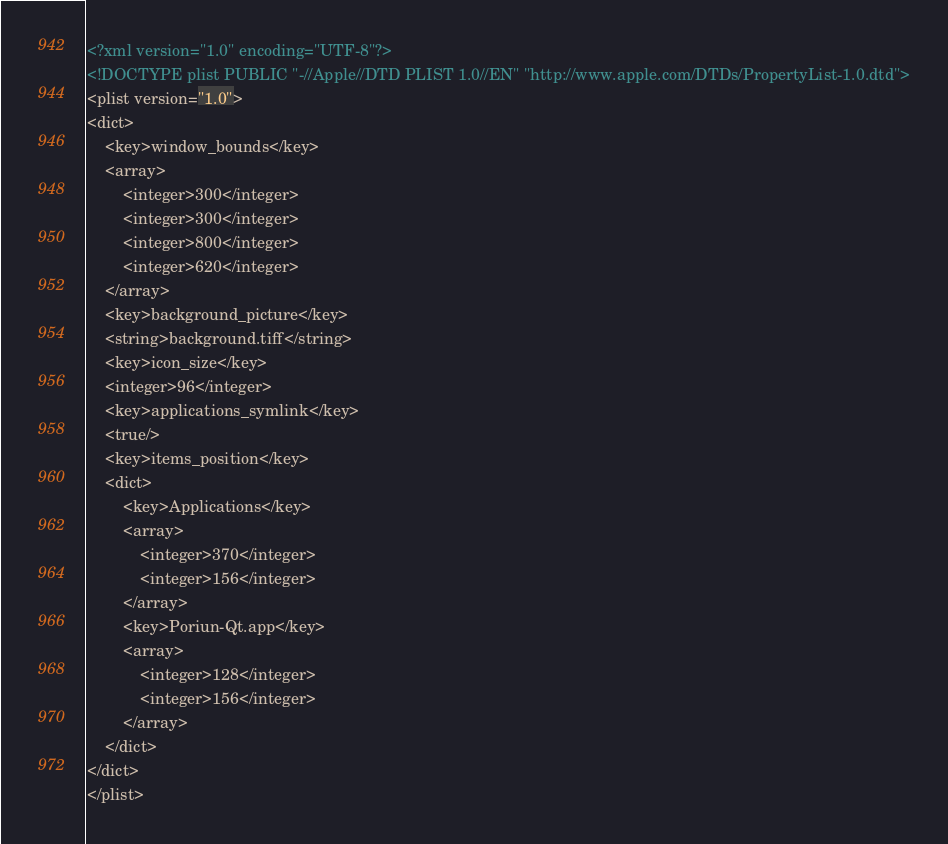Convert code to text. <code><loc_0><loc_0><loc_500><loc_500><_XML_><?xml version="1.0" encoding="UTF-8"?>
<!DOCTYPE plist PUBLIC "-//Apple//DTD PLIST 1.0//EN" "http://www.apple.com/DTDs/PropertyList-1.0.dtd">
<plist version="1.0">
<dict>
	<key>window_bounds</key>
	<array>
		<integer>300</integer>
		<integer>300</integer>
		<integer>800</integer>
		<integer>620</integer>
	</array>
	<key>background_picture</key>
	<string>background.tiff</string>
	<key>icon_size</key>
	<integer>96</integer>
	<key>applications_symlink</key>
	<true/>
	<key>items_position</key>
	<dict>
		<key>Applications</key>
		<array>
			<integer>370</integer>
			<integer>156</integer>
		</array>
		<key>Poriun-Qt.app</key>
		<array>
			<integer>128</integer>
			<integer>156</integer>
		</array>
	</dict>
</dict>
</plist>
</code> 